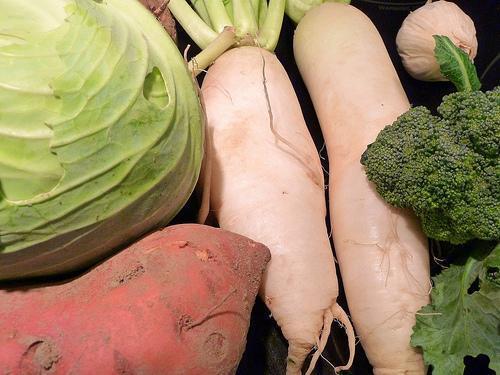How many pieces of broccoli are there?
Give a very brief answer. 1. How many parsnips are there?
Give a very brief answer. 2. How many potatoes are there?
Give a very brief answer. 1. 